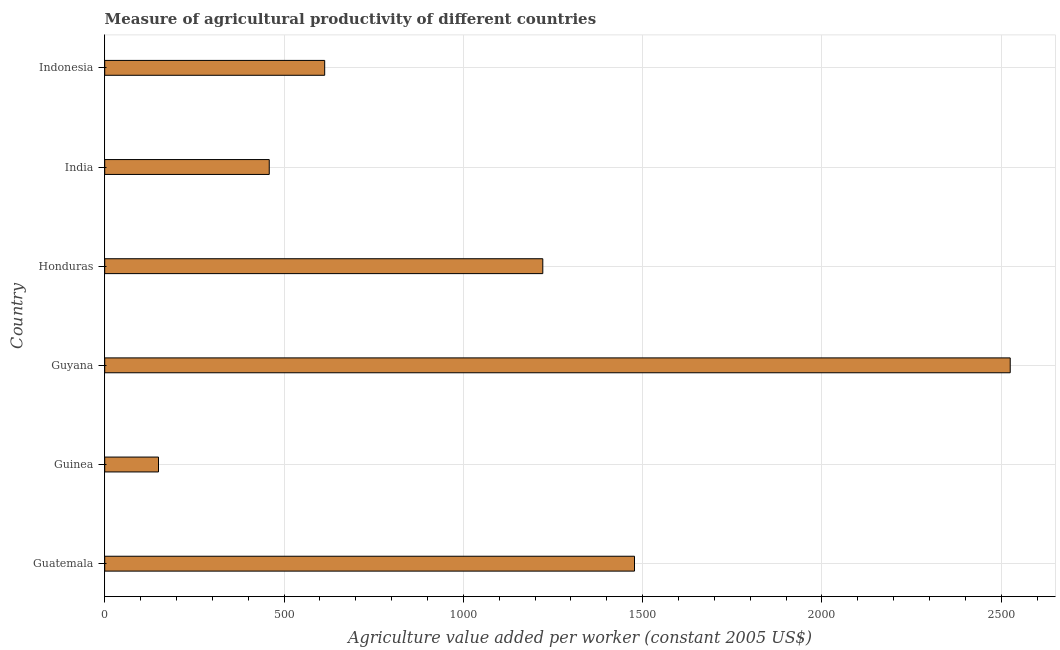Does the graph contain any zero values?
Your answer should be very brief. No. Does the graph contain grids?
Offer a very short reply. Yes. What is the title of the graph?
Your answer should be very brief. Measure of agricultural productivity of different countries. What is the label or title of the X-axis?
Your response must be concise. Agriculture value added per worker (constant 2005 US$). What is the label or title of the Y-axis?
Keep it short and to the point. Country. What is the agriculture value added per worker in Guinea?
Keep it short and to the point. 149.99. Across all countries, what is the maximum agriculture value added per worker?
Your answer should be very brief. 2525.08. Across all countries, what is the minimum agriculture value added per worker?
Make the answer very short. 149.99. In which country was the agriculture value added per worker maximum?
Provide a short and direct response. Guyana. In which country was the agriculture value added per worker minimum?
Offer a terse response. Guinea. What is the sum of the agriculture value added per worker?
Give a very brief answer. 6446.25. What is the difference between the agriculture value added per worker in Guinea and Guyana?
Keep it short and to the point. -2375.09. What is the average agriculture value added per worker per country?
Make the answer very short. 1074.38. What is the median agriculture value added per worker?
Offer a terse response. 917.51. In how many countries, is the agriculture value added per worker greater than 1300 US$?
Give a very brief answer. 2. What is the ratio of the agriculture value added per worker in Guinea to that in Indonesia?
Your response must be concise. 0.24. Is the difference between the agriculture value added per worker in Guatemala and Guinea greater than the difference between any two countries?
Offer a terse response. No. What is the difference between the highest and the second highest agriculture value added per worker?
Provide a succinct answer. 1047.74. What is the difference between the highest and the lowest agriculture value added per worker?
Your answer should be very brief. 2375.08. In how many countries, is the agriculture value added per worker greater than the average agriculture value added per worker taken over all countries?
Offer a very short reply. 3. How many countries are there in the graph?
Your response must be concise. 6. Are the values on the major ticks of X-axis written in scientific E-notation?
Your answer should be compact. No. What is the Agriculture value added per worker (constant 2005 US$) of Guatemala?
Make the answer very short. 1477.34. What is the Agriculture value added per worker (constant 2005 US$) of Guinea?
Provide a short and direct response. 149.99. What is the Agriculture value added per worker (constant 2005 US$) in Guyana?
Make the answer very short. 2525.08. What is the Agriculture value added per worker (constant 2005 US$) in Honduras?
Give a very brief answer. 1221.62. What is the Agriculture value added per worker (constant 2005 US$) in India?
Offer a very short reply. 458.81. What is the Agriculture value added per worker (constant 2005 US$) in Indonesia?
Keep it short and to the point. 613.41. What is the difference between the Agriculture value added per worker (constant 2005 US$) in Guatemala and Guinea?
Offer a terse response. 1327.35. What is the difference between the Agriculture value added per worker (constant 2005 US$) in Guatemala and Guyana?
Your response must be concise. -1047.74. What is the difference between the Agriculture value added per worker (constant 2005 US$) in Guatemala and Honduras?
Offer a terse response. 255.72. What is the difference between the Agriculture value added per worker (constant 2005 US$) in Guatemala and India?
Offer a terse response. 1018.52. What is the difference between the Agriculture value added per worker (constant 2005 US$) in Guatemala and Indonesia?
Your answer should be compact. 863.93. What is the difference between the Agriculture value added per worker (constant 2005 US$) in Guinea and Guyana?
Give a very brief answer. -2375.08. What is the difference between the Agriculture value added per worker (constant 2005 US$) in Guinea and Honduras?
Your answer should be compact. -1071.63. What is the difference between the Agriculture value added per worker (constant 2005 US$) in Guinea and India?
Provide a short and direct response. -308.82. What is the difference between the Agriculture value added per worker (constant 2005 US$) in Guinea and Indonesia?
Offer a terse response. -463.42. What is the difference between the Agriculture value added per worker (constant 2005 US$) in Guyana and Honduras?
Offer a very short reply. 1303.46. What is the difference between the Agriculture value added per worker (constant 2005 US$) in Guyana and India?
Keep it short and to the point. 2066.26. What is the difference between the Agriculture value added per worker (constant 2005 US$) in Guyana and Indonesia?
Provide a succinct answer. 1911.67. What is the difference between the Agriculture value added per worker (constant 2005 US$) in Honduras and India?
Provide a succinct answer. 762.8. What is the difference between the Agriculture value added per worker (constant 2005 US$) in Honduras and Indonesia?
Provide a short and direct response. 608.21. What is the difference between the Agriculture value added per worker (constant 2005 US$) in India and Indonesia?
Your answer should be compact. -154.6. What is the ratio of the Agriculture value added per worker (constant 2005 US$) in Guatemala to that in Guinea?
Ensure brevity in your answer.  9.85. What is the ratio of the Agriculture value added per worker (constant 2005 US$) in Guatemala to that in Guyana?
Your response must be concise. 0.58. What is the ratio of the Agriculture value added per worker (constant 2005 US$) in Guatemala to that in Honduras?
Keep it short and to the point. 1.21. What is the ratio of the Agriculture value added per worker (constant 2005 US$) in Guatemala to that in India?
Offer a terse response. 3.22. What is the ratio of the Agriculture value added per worker (constant 2005 US$) in Guatemala to that in Indonesia?
Provide a succinct answer. 2.41. What is the ratio of the Agriculture value added per worker (constant 2005 US$) in Guinea to that in Guyana?
Give a very brief answer. 0.06. What is the ratio of the Agriculture value added per worker (constant 2005 US$) in Guinea to that in Honduras?
Offer a terse response. 0.12. What is the ratio of the Agriculture value added per worker (constant 2005 US$) in Guinea to that in India?
Your answer should be very brief. 0.33. What is the ratio of the Agriculture value added per worker (constant 2005 US$) in Guinea to that in Indonesia?
Your answer should be very brief. 0.24. What is the ratio of the Agriculture value added per worker (constant 2005 US$) in Guyana to that in Honduras?
Offer a terse response. 2.07. What is the ratio of the Agriculture value added per worker (constant 2005 US$) in Guyana to that in India?
Provide a short and direct response. 5.5. What is the ratio of the Agriculture value added per worker (constant 2005 US$) in Guyana to that in Indonesia?
Your answer should be compact. 4.12. What is the ratio of the Agriculture value added per worker (constant 2005 US$) in Honduras to that in India?
Give a very brief answer. 2.66. What is the ratio of the Agriculture value added per worker (constant 2005 US$) in Honduras to that in Indonesia?
Offer a terse response. 1.99. What is the ratio of the Agriculture value added per worker (constant 2005 US$) in India to that in Indonesia?
Your response must be concise. 0.75. 